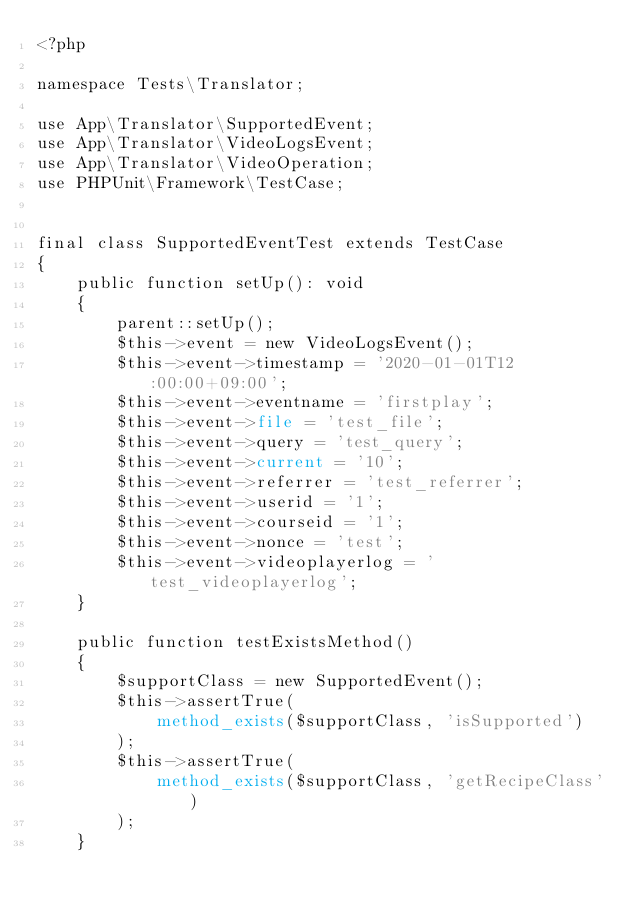Convert code to text. <code><loc_0><loc_0><loc_500><loc_500><_PHP_><?php

namespace Tests\Translator;

use App\Translator\SupportedEvent;
use App\Translator\VideoLogsEvent;
use App\Translator\VideoOperation;
use PHPUnit\Framework\TestCase;


final class SupportedEventTest extends TestCase
{
    public function setUp(): void
    {
        parent::setUp();
        $this->event = new VideoLogsEvent();
        $this->event->timestamp = '2020-01-01T12:00:00+09:00';
        $this->event->eventname = 'firstplay';
        $this->event->file = 'test_file';
        $this->event->query = 'test_query';
        $this->event->current = '10';
        $this->event->referrer = 'test_referrer';
        $this->event->userid = '1';
        $this->event->courseid = '1';
        $this->event->nonce = 'test';
        $this->event->videoplayerlog = 'test_videoplayerlog';
    }

    public function testExistsMethod()
    {
        $supportClass = new SupportedEvent();
        $this->assertTrue(
            method_exists($supportClass, 'isSupported')
        );
        $this->assertTrue(
            method_exists($supportClass, 'getRecipeClass')
        );
    }
</code> 